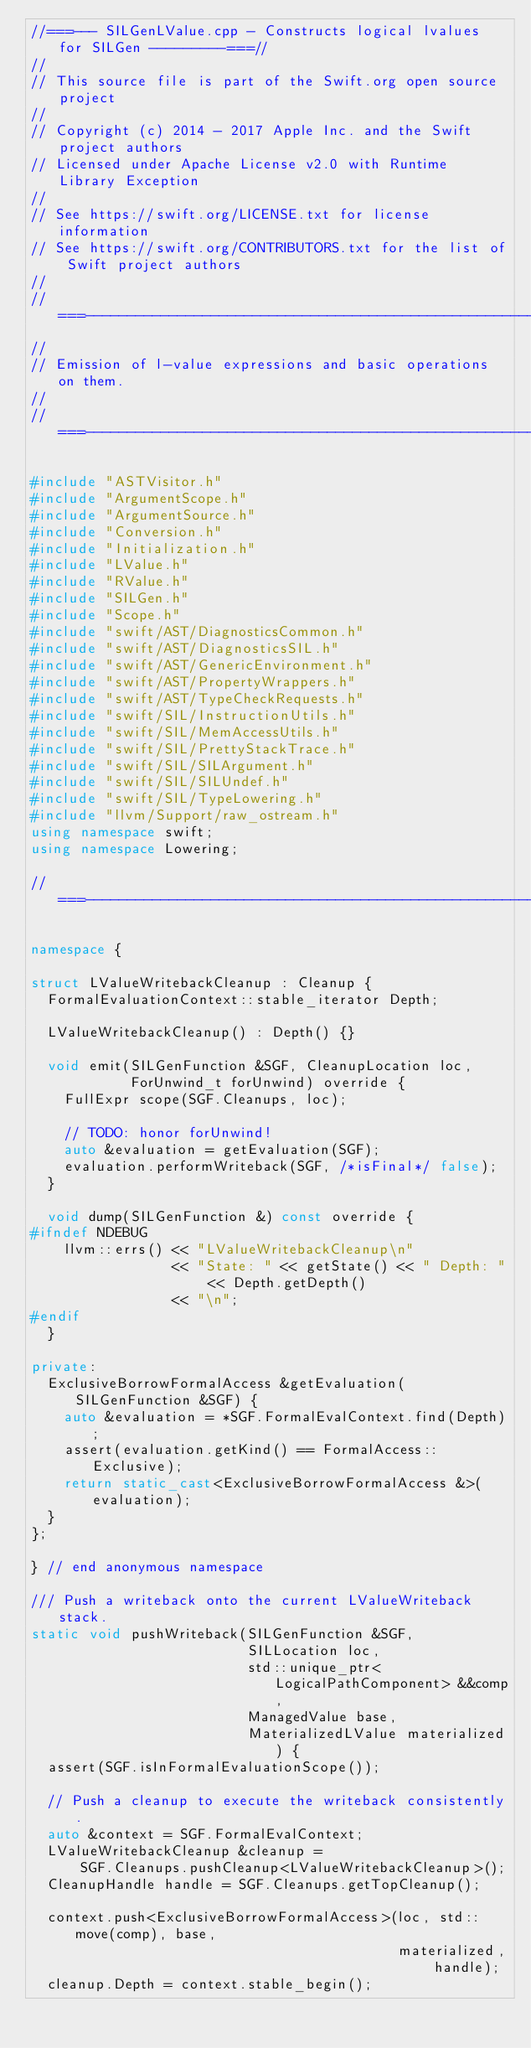<code> <loc_0><loc_0><loc_500><loc_500><_C++_>//===--- SILGenLValue.cpp - Constructs logical lvalues for SILGen ---------===//
//
// This source file is part of the Swift.org open source project
//
// Copyright (c) 2014 - 2017 Apple Inc. and the Swift project authors
// Licensed under Apache License v2.0 with Runtime Library Exception
//
// See https://swift.org/LICENSE.txt for license information
// See https://swift.org/CONTRIBUTORS.txt for the list of Swift project authors
//
//===----------------------------------------------------------------------===//
//
// Emission of l-value expressions and basic operations on them.
//
//===----------------------------------------------------------------------===//

#include "ASTVisitor.h"
#include "ArgumentScope.h"
#include "ArgumentSource.h"
#include "Conversion.h"
#include "Initialization.h"
#include "LValue.h"
#include "RValue.h"
#include "SILGen.h"
#include "Scope.h"
#include "swift/AST/DiagnosticsCommon.h"
#include "swift/AST/DiagnosticsSIL.h"
#include "swift/AST/GenericEnvironment.h"
#include "swift/AST/PropertyWrappers.h"
#include "swift/AST/TypeCheckRequests.h"
#include "swift/SIL/InstructionUtils.h"
#include "swift/SIL/MemAccessUtils.h"
#include "swift/SIL/PrettyStackTrace.h"
#include "swift/SIL/SILArgument.h"
#include "swift/SIL/SILUndef.h"
#include "swift/SIL/TypeLowering.h"
#include "llvm/Support/raw_ostream.h"
using namespace swift;
using namespace Lowering;

//===----------------------------------------------------------------------===//

namespace {

struct LValueWritebackCleanup : Cleanup {
  FormalEvaluationContext::stable_iterator Depth;

  LValueWritebackCleanup() : Depth() {}

  void emit(SILGenFunction &SGF, CleanupLocation loc,
            ForUnwind_t forUnwind) override {
    FullExpr scope(SGF.Cleanups, loc);

    // TODO: honor forUnwind!
    auto &evaluation = getEvaluation(SGF);
    evaluation.performWriteback(SGF, /*isFinal*/ false);
  }

  void dump(SILGenFunction &) const override {
#ifndef NDEBUG
    llvm::errs() << "LValueWritebackCleanup\n"
                 << "State: " << getState() << " Depth: " << Depth.getDepth()
                 << "\n";
#endif
  }

private:
  ExclusiveBorrowFormalAccess &getEvaluation(SILGenFunction &SGF) {
    auto &evaluation = *SGF.FormalEvalContext.find(Depth);
    assert(evaluation.getKind() == FormalAccess::Exclusive);
    return static_cast<ExclusiveBorrowFormalAccess &>(evaluation);
  }
};

} // end anonymous namespace

/// Push a writeback onto the current LValueWriteback stack.
static void pushWriteback(SILGenFunction &SGF,
                          SILLocation loc,
                          std::unique_ptr<LogicalPathComponent> &&comp,
                          ManagedValue base,
                          MaterializedLValue materialized) {
  assert(SGF.isInFormalEvaluationScope());

  // Push a cleanup to execute the writeback consistently.
  auto &context = SGF.FormalEvalContext;
  LValueWritebackCleanup &cleanup =
      SGF.Cleanups.pushCleanup<LValueWritebackCleanup>();
  CleanupHandle handle = SGF.Cleanups.getTopCleanup();

  context.push<ExclusiveBorrowFormalAccess>(loc, std::move(comp), base,
                                            materialized, handle);
  cleanup.Depth = context.stable_begin();</code> 